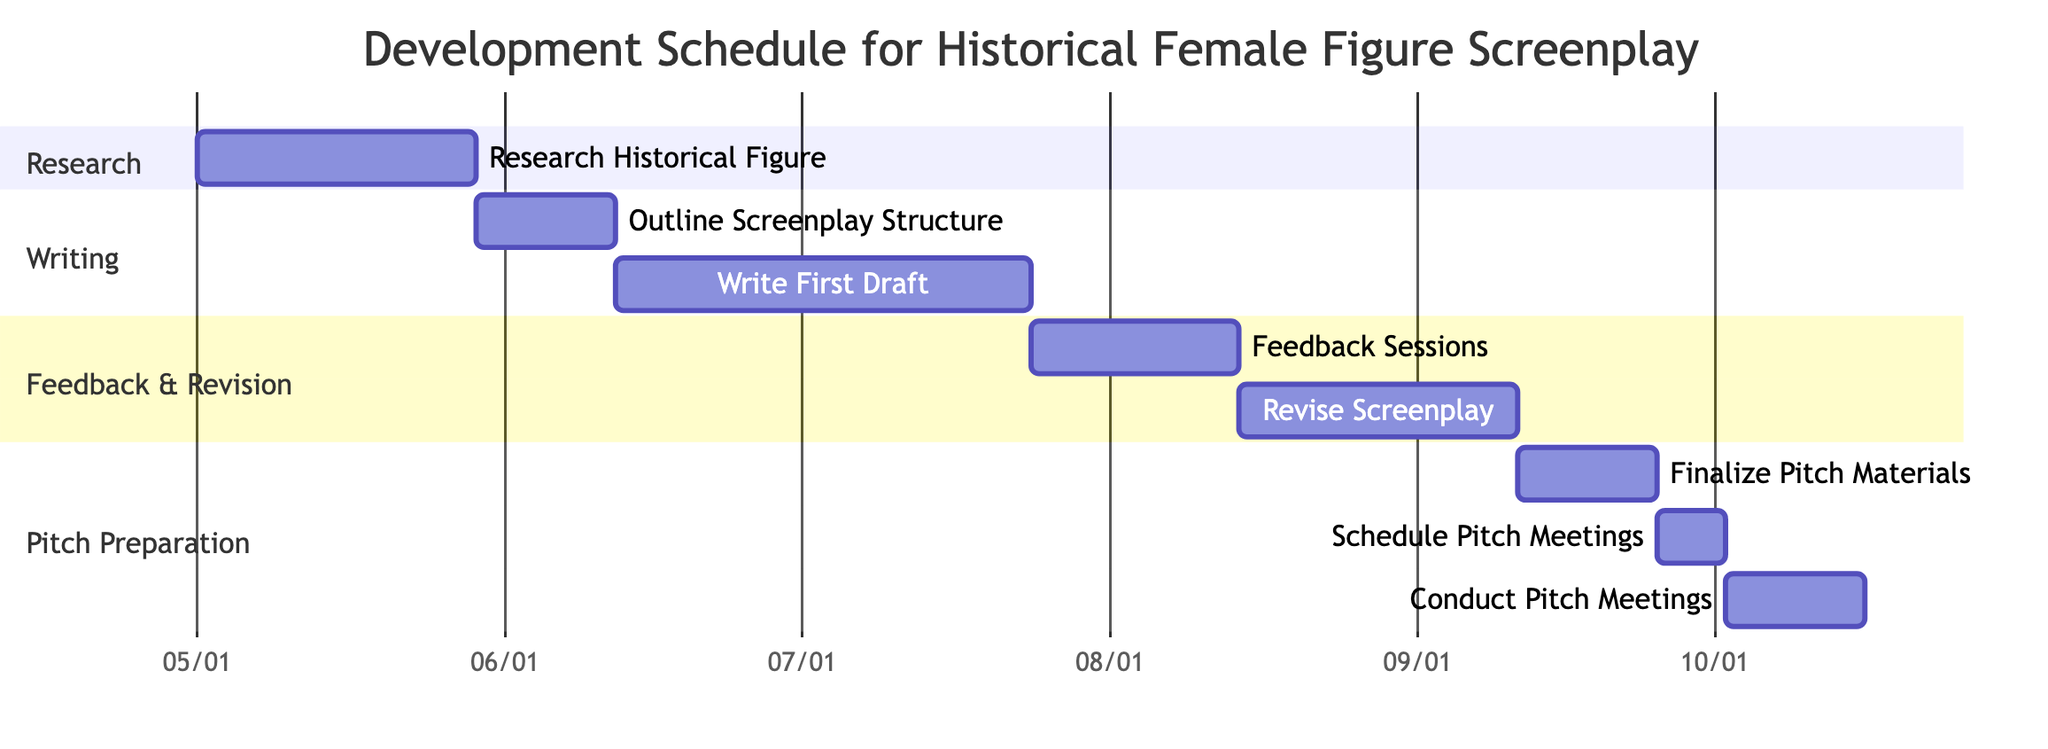What is the total duration for the Research stage? In the Gantt chart, the Research stage consists of a single task labeled "Research Historical Figure" with a duration of 4 weeks. Therefore, the total duration for this stage is directly taken from the task.
Answer: 4 weeks How many weeks are allocated for writing the first draft? The Gantt chart provides the duration of the task "Write First Draft," which is specifically stated as 6 weeks. This figure represents the time dedicated to this part of the screenplay development process.
Answer: 6 weeks What stage comes immediately after Feedback Sessions? By examining the Gantt chart sequence, "Feedback Sessions" is shown to be followed by "Revise Screenplay." The stages are organized in a sequential order, making it clear which task follows another.
Answer: Revise Screenplay How many total stages are listed in the development schedule? The total number of stages can be counted from the Gantt chart, where each unique task represents a stage. There are eight distinct tasks listed: Research Historical Figure, Outline Screenplay Structure, Write First Draft, Feedback Sessions, Revise Screenplay, Finalize Pitch Materials, Schedule Pitch Meetings, and Conduct Pitch Meetings.
Answer: 8 What is the duration for the final stage, Conduct Pitch Meetings? Referring to the Gantt chart, the duration mentioned for "Conduct Pitch Meetings" is 2 weeks, which indicates the time allocated to this specific activity before concluding the development cycle.
Answer: 2 weeks Which task has the longest duration in the development schedule? To find the longest duration, each task's allocated weeks need to be compared. "Write First Draft" has a duration of 6 weeks, while "Research Historical Figure" has 4 weeks, and others vary between 1 to 4 weeks. Since 6 weeks is the highest value, it indicates that this task takes the longest time.
Answer: Write First Draft How long does it take from the start of the Research stage to conducting pitch meetings? To determine this, we must sum the durations of all the tasks leading up to "Conduct Pitch Meetings." The durations are: 4 weeks (Research) + 2 weeks (Outline) + 6 weeks (First Draft) + 3 weeks (Feedback) + 4 weeks (Revise) + 2 weeks (Finalize) + 1 week (Schedule) = 22 weeks total. This represents the cumulative time from the start to the pitch meetings.
Answer: 22 weeks How many weeks total are allocated for the Feedback & Revision section? This section consists of two tasks: "Feedback Sessions" lasting 3 weeks and "Revise Screenplay" lasting 4 weeks. By adding these durations together (3 weeks + 4 weeks), we get the total time for this section.
Answer: 7 weeks 